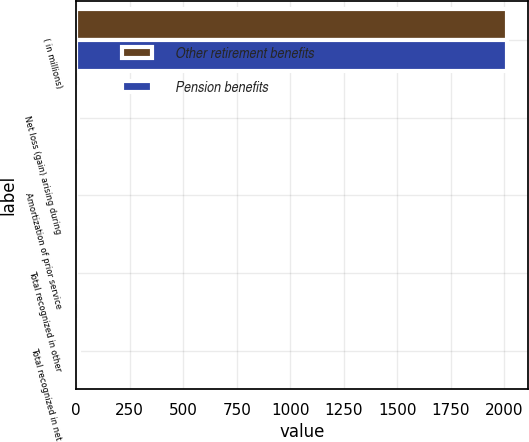Convert chart. <chart><loc_0><loc_0><loc_500><loc_500><stacked_bar_chart><ecel><fcel>( in millions)<fcel>Net loss (gain) arising during<fcel>Amortization of prior service<fcel>Total recognized in other<fcel>Total recognized in net<nl><fcel>Other retirement benefits<fcel>2010<fcel>9.1<fcel>1.1<fcel>0.7<fcel>13.5<nl><fcel>Pension benefits<fcel>2010<fcel>1.5<fcel>0.1<fcel>1.5<fcel>0.4<nl></chart> 